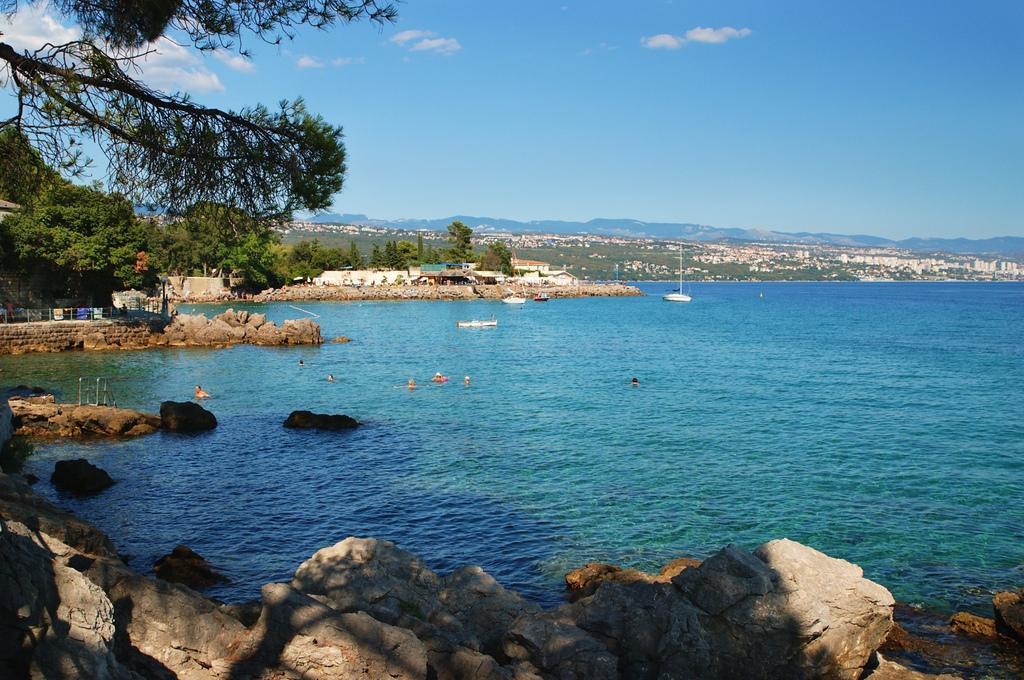In one or two sentences, can you explain what this image depicts? In this image there is water and we can see a boat on the water. At the bottom there are rocks. In the background there are trees, hills and sky. 